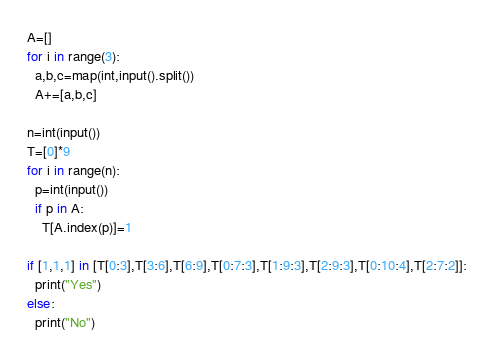<code> <loc_0><loc_0><loc_500><loc_500><_Python_>A=[]
for i in range(3):
  a,b,c=map(int,input().split())
  A+=[a,b,c]
  
n=int(input())
T=[0]*9
for i in range(n):
  p=int(input())
  if p in A:
    T[A.index(p)]=1
    
if [1,1,1] in [T[0:3],T[3:6],T[6:9],T[0:7:3],T[1:9:3],T[2:9:3],T[0:10:4],T[2:7:2]]:
  print("Yes")
else:
  print("No")</code> 